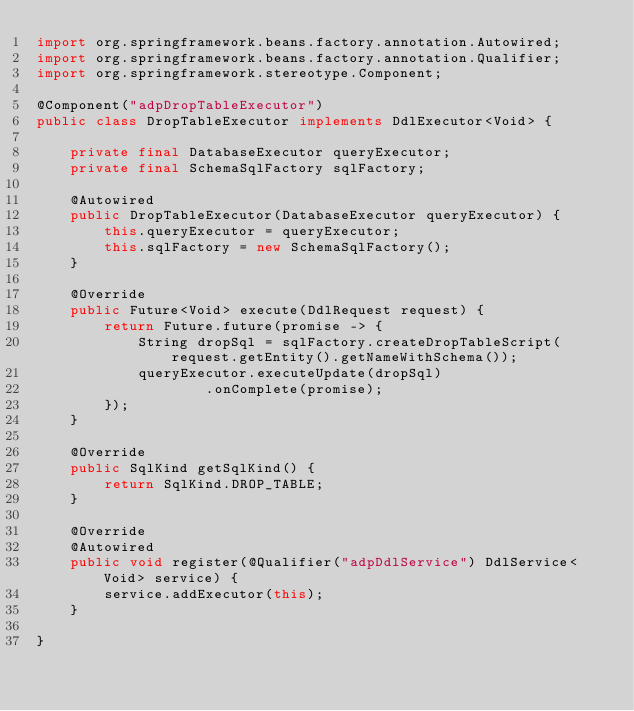<code> <loc_0><loc_0><loc_500><loc_500><_Java_>import org.springframework.beans.factory.annotation.Autowired;
import org.springframework.beans.factory.annotation.Qualifier;
import org.springframework.stereotype.Component;

@Component("adpDropTableExecutor")
public class DropTableExecutor implements DdlExecutor<Void> {

    private final DatabaseExecutor queryExecutor;
    private final SchemaSqlFactory sqlFactory;

    @Autowired
    public DropTableExecutor(DatabaseExecutor queryExecutor) {
        this.queryExecutor = queryExecutor;
        this.sqlFactory = new SchemaSqlFactory();
    }

    @Override
    public Future<Void> execute(DdlRequest request) {
        return Future.future(promise -> {
            String dropSql = sqlFactory.createDropTableScript(request.getEntity().getNameWithSchema());
            queryExecutor.executeUpdate(dropSql)
                    .onComplete(promise);
        });
    }

    @Override
    public SqlKind getSqlKind() {
        return SqlKind.DROP_TABLE;
    }

    @Override
    @Autowired
    public void register(@Qualifier("adpDdlService") DdlService<Void> service) {
        service.addExecutor(this);
    }

}
</code> 